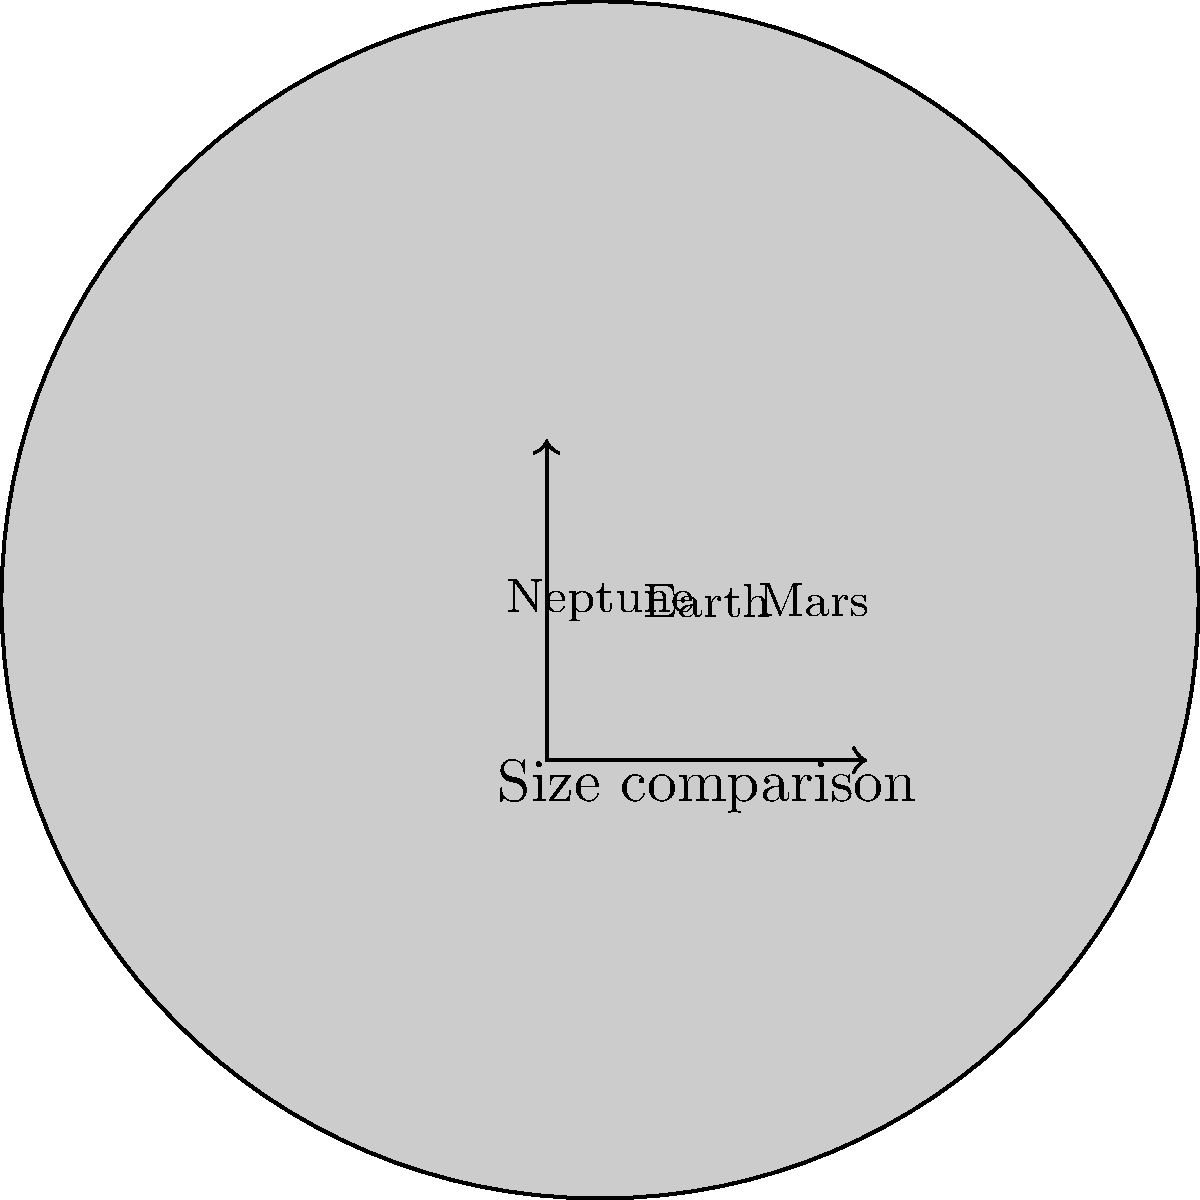As a remote worker who regularly uploads image files, you come across a scaled representation of Earth, Mars, and Neptune. Given that the radii of Earth, Mars, and Neptune are approximately 6,371 km, 3,390 km, and 24,622 km respectively, which planet's representation in the image is not accurately scaled compared to the others? To determine which planet's representation is not accurately scaled, we need to compare the ratios of their actual sizes to their depicted sizes in the image:

1. Calculate the ratios of the actual radii:
   Earth to Mars ratio: $\frac{6,371}{3,390} \approx 1.88$
   Earth to Neptune ratio: $\frac{24,622}{6,371} \approx 3.86$
   
2. Measure the radii in the image (using the given scale factor of 10):
   Earth: $6.371 * 10 = 63.71$ units
   Mars: $3.39 * 10 = 33.9$ units
   Neptune: $11.209 * 10 = 112.09$ units
   
3. Calculate the ratios of the depicted radii:
   Earth to Mars ratio in image: $\frac{63.71}{33.9} \approx 1.88$
   Earth to Neptune ratio in image: $\frac{112.09}{63.71} \approx 1.76$
   
4. Compare the actual ratios to the depicted ratios:
   Earth to Mars ratio is correct: $1.88 \approx 1.88$
   Earth to Neptune ratio is incorrect: $3.86 \neq 1.76$

Therefore, Neptune's representation is not accurately scaled compared to Earth and Mars.
Answer: Neptune 